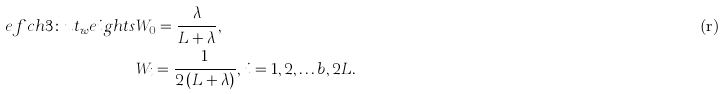Convert formula to latex. <formula><loc_0><loc_0><loc_500><loc_500>\tag r e f { c h 3 \colon u t _ { w } e i g h t s } & W _ { 0 } = \frac { \lambda } { L + \lambda } , \\ & W _ { i } = \frac { 1 } { 2 \left ( L + \lambda \right ) } , \, i = 1 , 2 , \dots b , 2 L . \\</formula> 